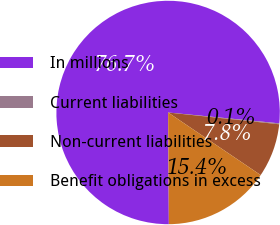<chart> <loc_0><loc_0><loc_500><loc_500><pie_chart><fcel>In millions<fcel>Current liabilities<fcel>Non-current liabilities<fcel>Benefit obligations in excess<nl><fcel>76.65%<fcel>0.13%<fcel>7.78%<fcel>15.43%<nl></chart> 